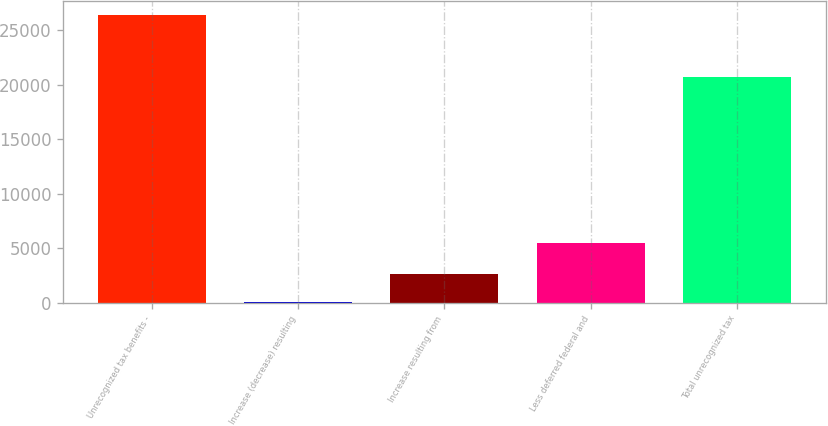Convert chart. <chart><loc_0><loc_0><loc_500><loc_500><bar_chart><fcel>Unrecognized tax benefits -<fcel>Increase (decrease) resulting<fcel>Increase resulting from<fcel>Less deferred federal and<fcel>Total unrecognized tax<nl><fcel>26337.1<fcel>22<fcel>2640.1<fcel>5503<fcel>20700<nl></chart> 